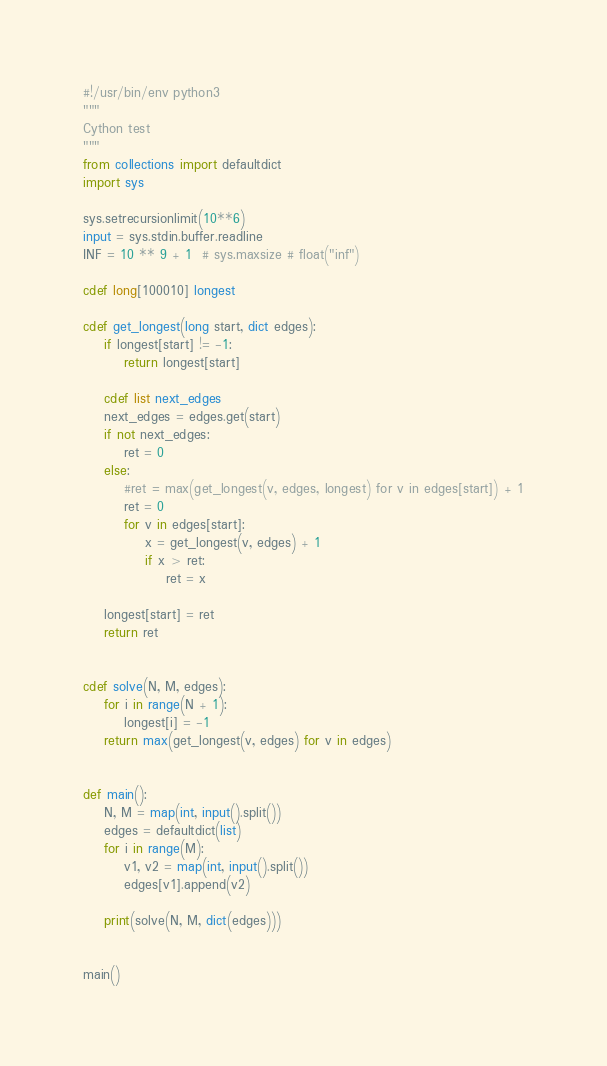Convert code to text. <code><loc_0><loc_0><loc_500><loc_500><_Cython_>#!/usr/bin/env python3
"""
Cython test
"""
from collections import defaultdict
import sys

sys.setrecursionlimit(10**6)
input = sys.stdin.buffer.readline
INF = 10 ** 9 + 1  # sys.maxsize # float("inf")

cdef long[100010] longest

cdef get_longest(long start, dict edges):
    if longest[start] != -1:
        return longest[start]

    cdef list next_edges
    next_edges = edges.get(start)
    if not next_edges:
        ret = 0
    else:
        #ret = max(get_longest(v, edges, longest) for v in edges[start]) + 1
        ret = 0
        for v in edges[start]:
            x = get_longest(v, edges) + 1
            if x > ret:
                ret = x

    longest[start] = ret
    return ret


cdef solve(N, M, edges):
    for i in range(N + 1):
        longest[i] = -1
    return max(get_longest(v, edges) for v in edges)


def main():
    N, M = map(int, input().split())
    edges = defaultdict(list)
    for i in range(M):
        v1, v2 = map(int, input().split())
        edges[v1].append(v2)

    print(solve(N, M, dict(edges)))


main()
</code> 